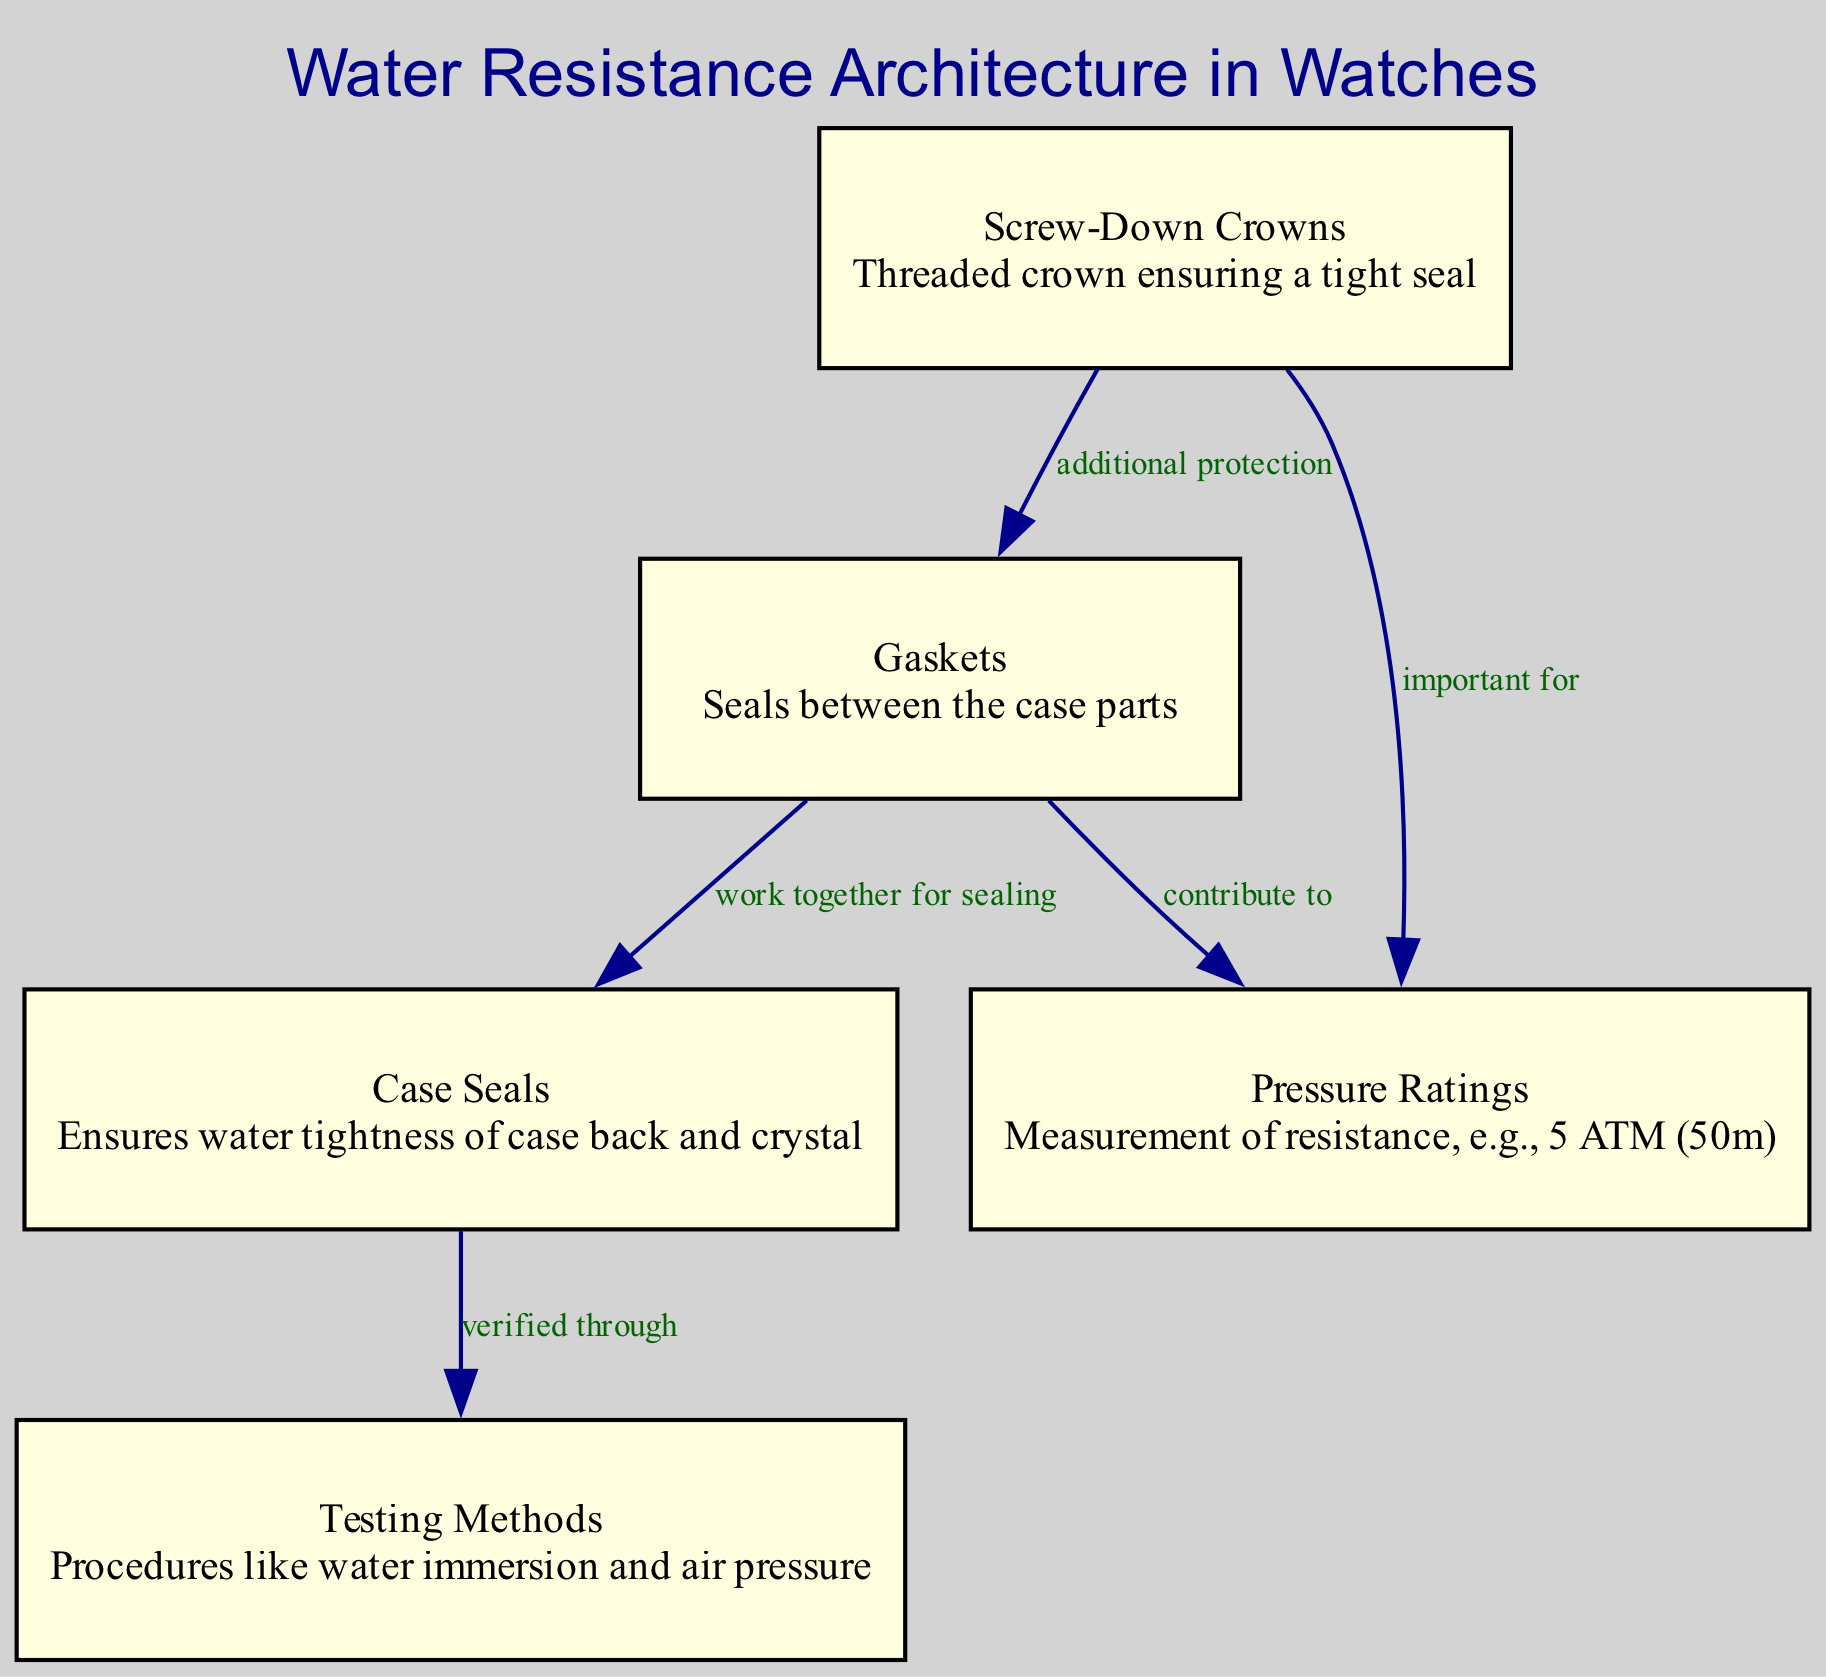What are the components that work together for sealing? The diagram indicates that gaskets and case seals work together for sealing, as represented by the edge label connecting them.
Answer: gaskets, case seals What contributes to pressure ratings in the watch mechanism? The edge from gaskets to pressure ratings in the diagram indicates that gaskets contribute to the pressure ratings, which is an important aspect of water resistance.
Answer: gaskets How many nodes are shown in the diagram? The diagram has five nodes, which are gaskets, screw-down crowns, case seals, pressure ratings, and testing methods.
Answer: five What provides additional protection against water intrusion? The diagram shows that screw-down crowns provide additional protection, indicated by the edge label between screw-down crowns and gaskets.
Answer: screw-down crowns How is water tightness of the case back and crystal ensured? According to the diagram, case seals ensure the water tightness of the case back and crystal, as indicated by its description and connected relationships.
Answer: case seals What verifies the effectiveness of case seals? The diagram specifies that case seals are verified through testing methods, which is shown in the edge connecting these two nodes.
Answer: testing methods Which methods are used to test water resistance? The diagram lists testing methods, which include procedures like water immersion and air pressure, connecting them to the case seals.
Answer: testing methods What is an example of a pressure rating in watches? The description under pressure ratings gives an example of a measurement of resistance such as 5 ATM (50m).
Answer: 5 ATM (50m) What is the function of screw-down crowns? The diagram shows that screw-down crowns ensure a tight seal, as stated in its description, which is crucial for water resistance.
Answer: tight seal 